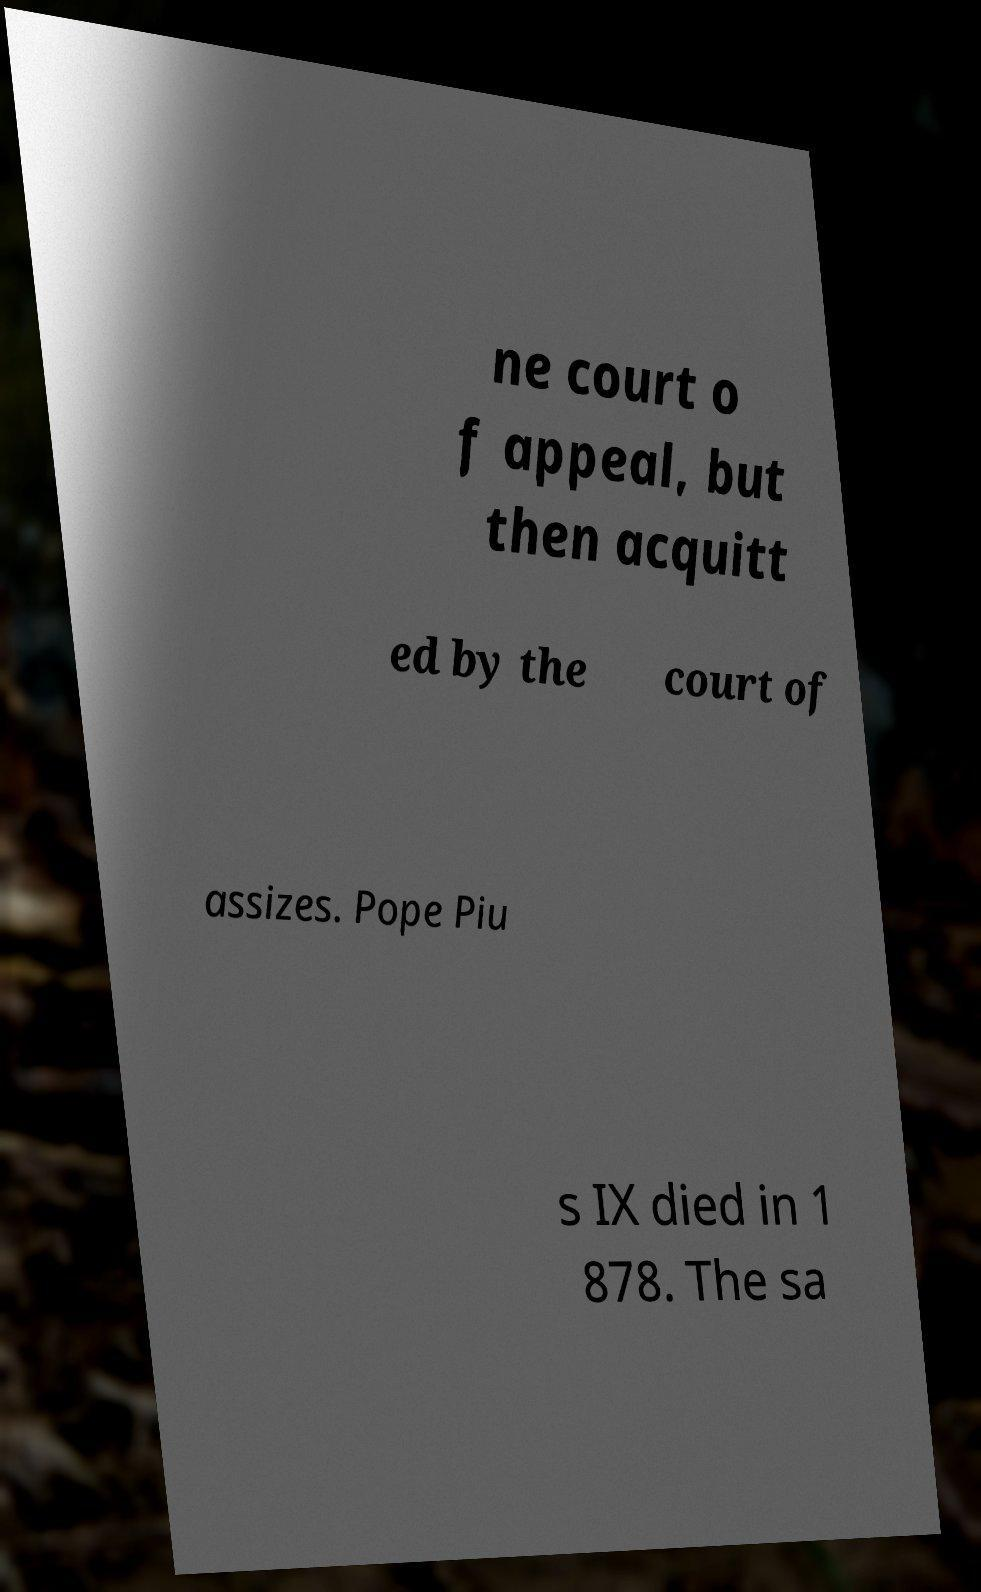Can you read and provide the text displayed in the image?This photo seems to have some interesting text. Can you extract and type it out for me? ne court o f appeal, but then acquitt ed by the court of assizes. Pope Piu s IX died in 1 878. The sa 